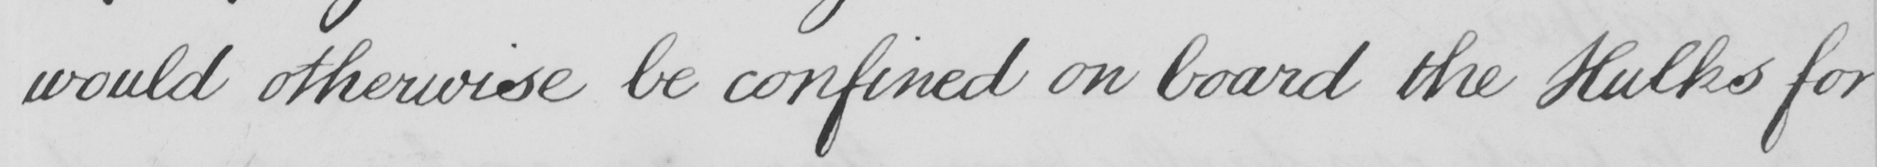Please transcribe the handwritten text in this image. would otherwise be confined on board the Hulks for 